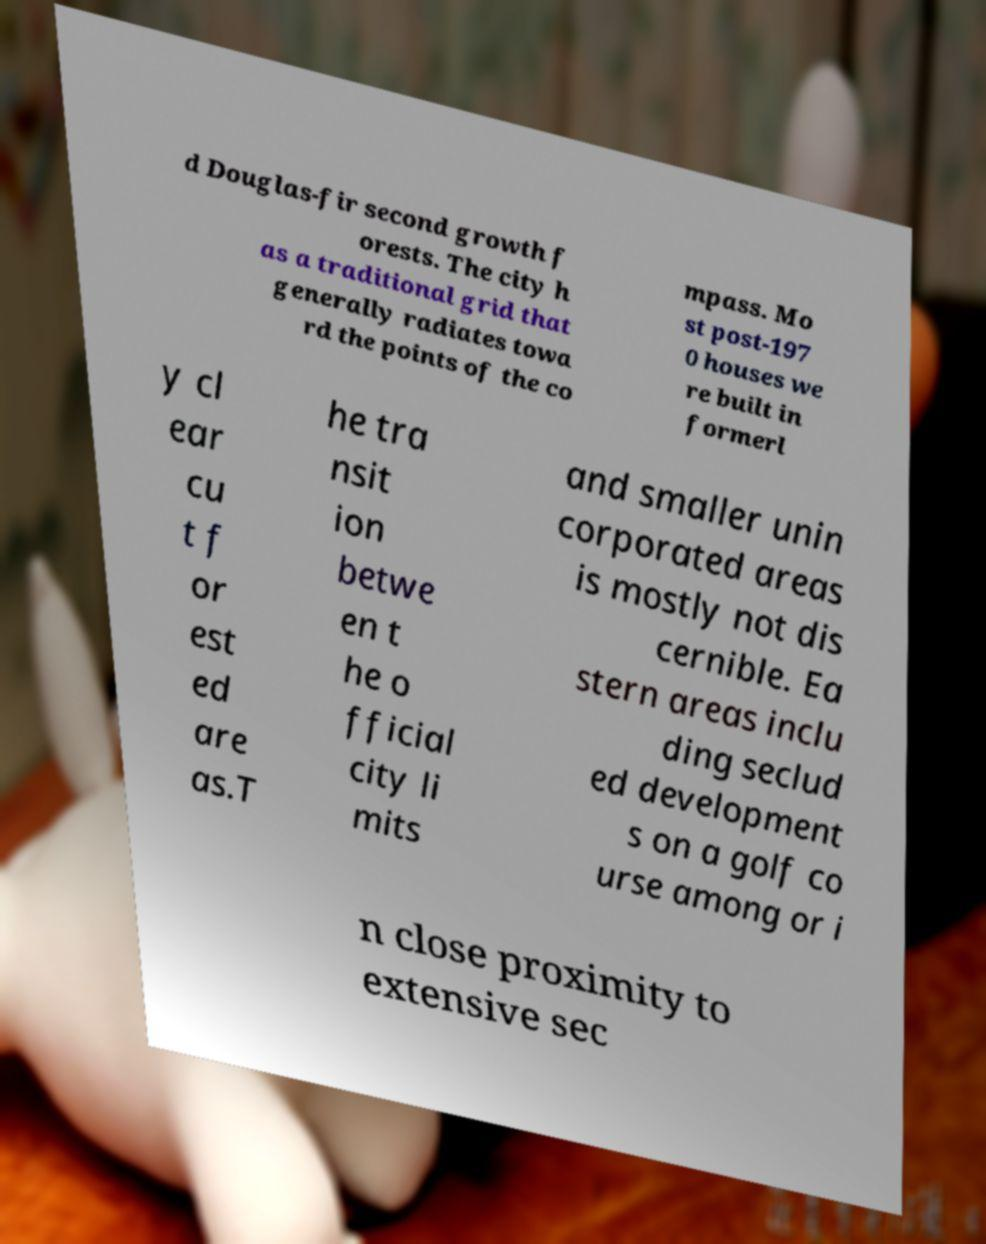Please identify and transcribe the text found in this image. d Douglas-fir second growth f orests. The city h as a traditional grid that generally radiates towa rd the points of the co mpass. Mo st post-197 0 houses we re built in formerl y cl ear cu t f or est ed are as.T he tra nsit ion betwe en t he o fficial city li mits and smaller unin corporated areas is mostly not dis cernible. Ea stern areas inclu ding seclud ed development s on a golf co urse among or i n close proximity to extensive sec 